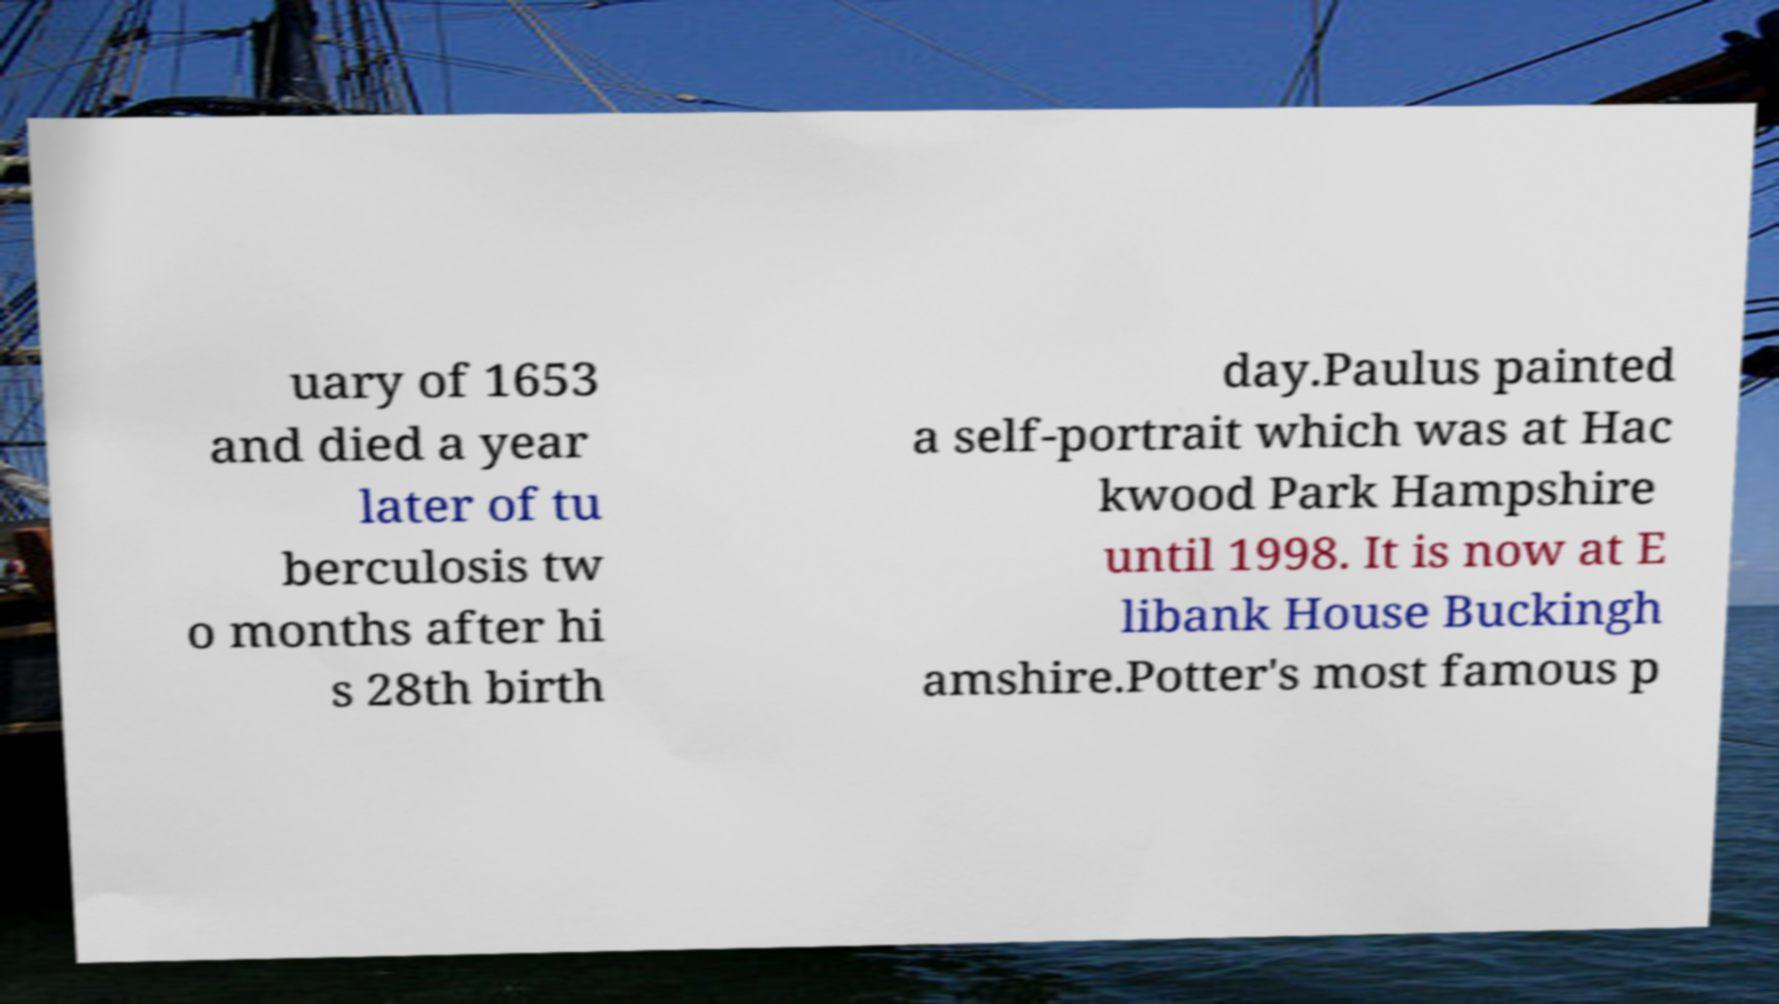Could you assist in decoding the text presented in this image and type it out clearly? uary of 1653 and died a year later of tu berculosis tw o months after hi s 28th birth day.Paulus painted a self-portrait which was at Hac kwood Park Hampshire until 1998. It is now at E libank House Buckingh amshire.Potter's most famous p 